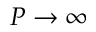<formula> <loc_0><loc_0><loc_500><loc_500>P \rightarrow \infty</formula> 